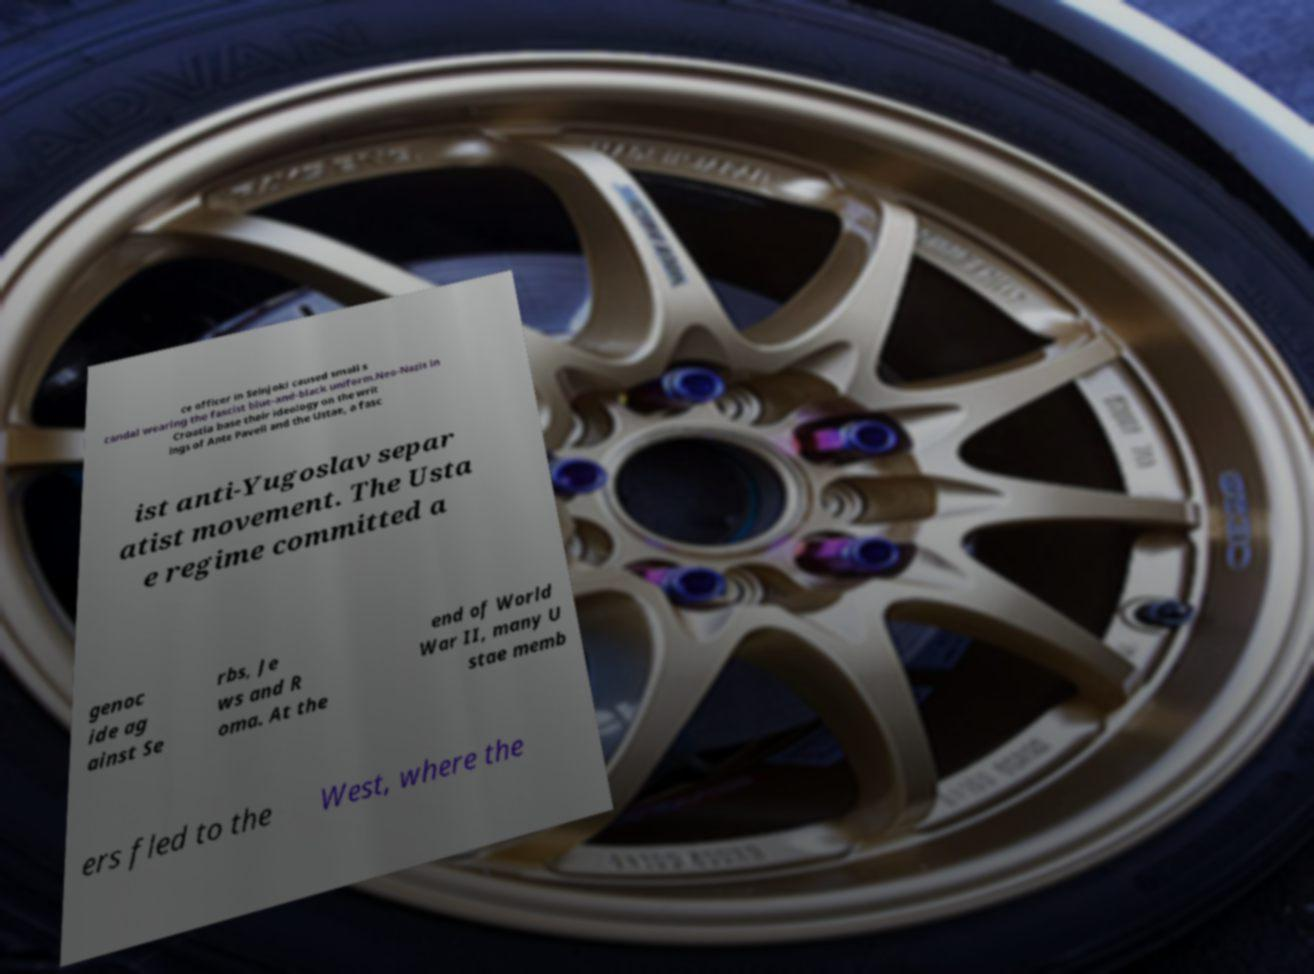Please read and relay the text visible in this image. What does it say? ce officer in Seinjoki caused small s candal wearing the fascist blue-and-black uniform.Neo-Nazis in Croatia base their ideology on the writ ings of Ante Paveli and the Ustae, a fasc ist anti-Yugoslav separ atist movement. The Usta e regime committed a genoc ide ag ainst Se rbs, Je ws and R oma. At the end of World War II, many U stae memb ers fled to the West, where the 